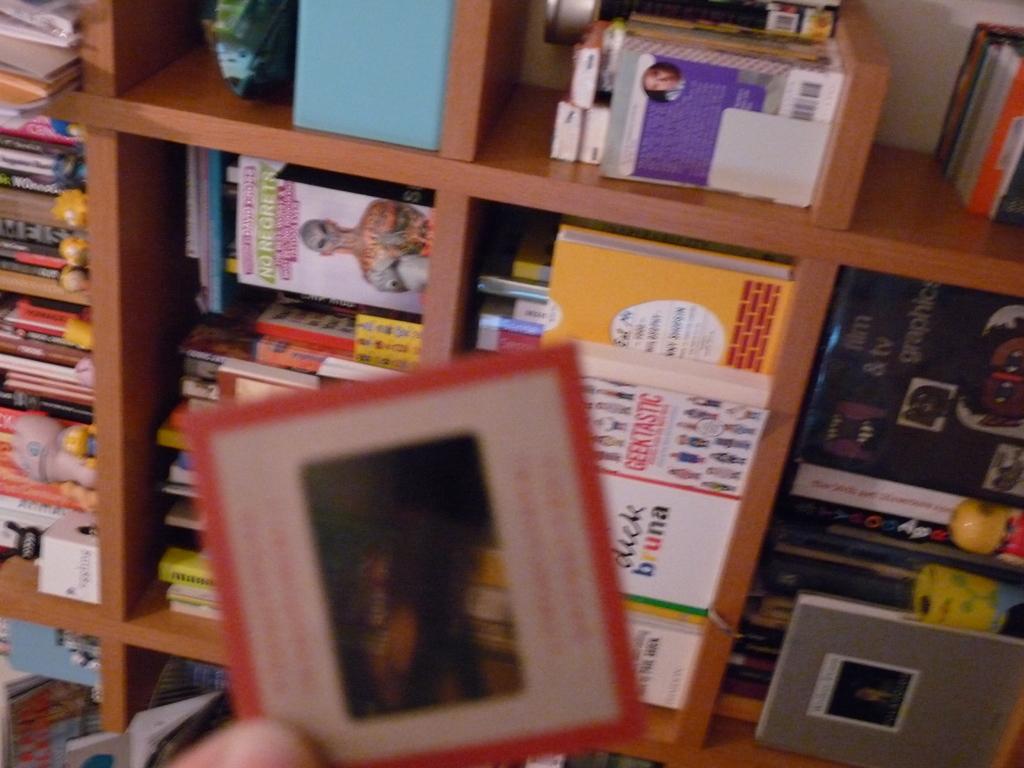What is written on one of the books on the shelves?
Make the answer very short. No regrets. 